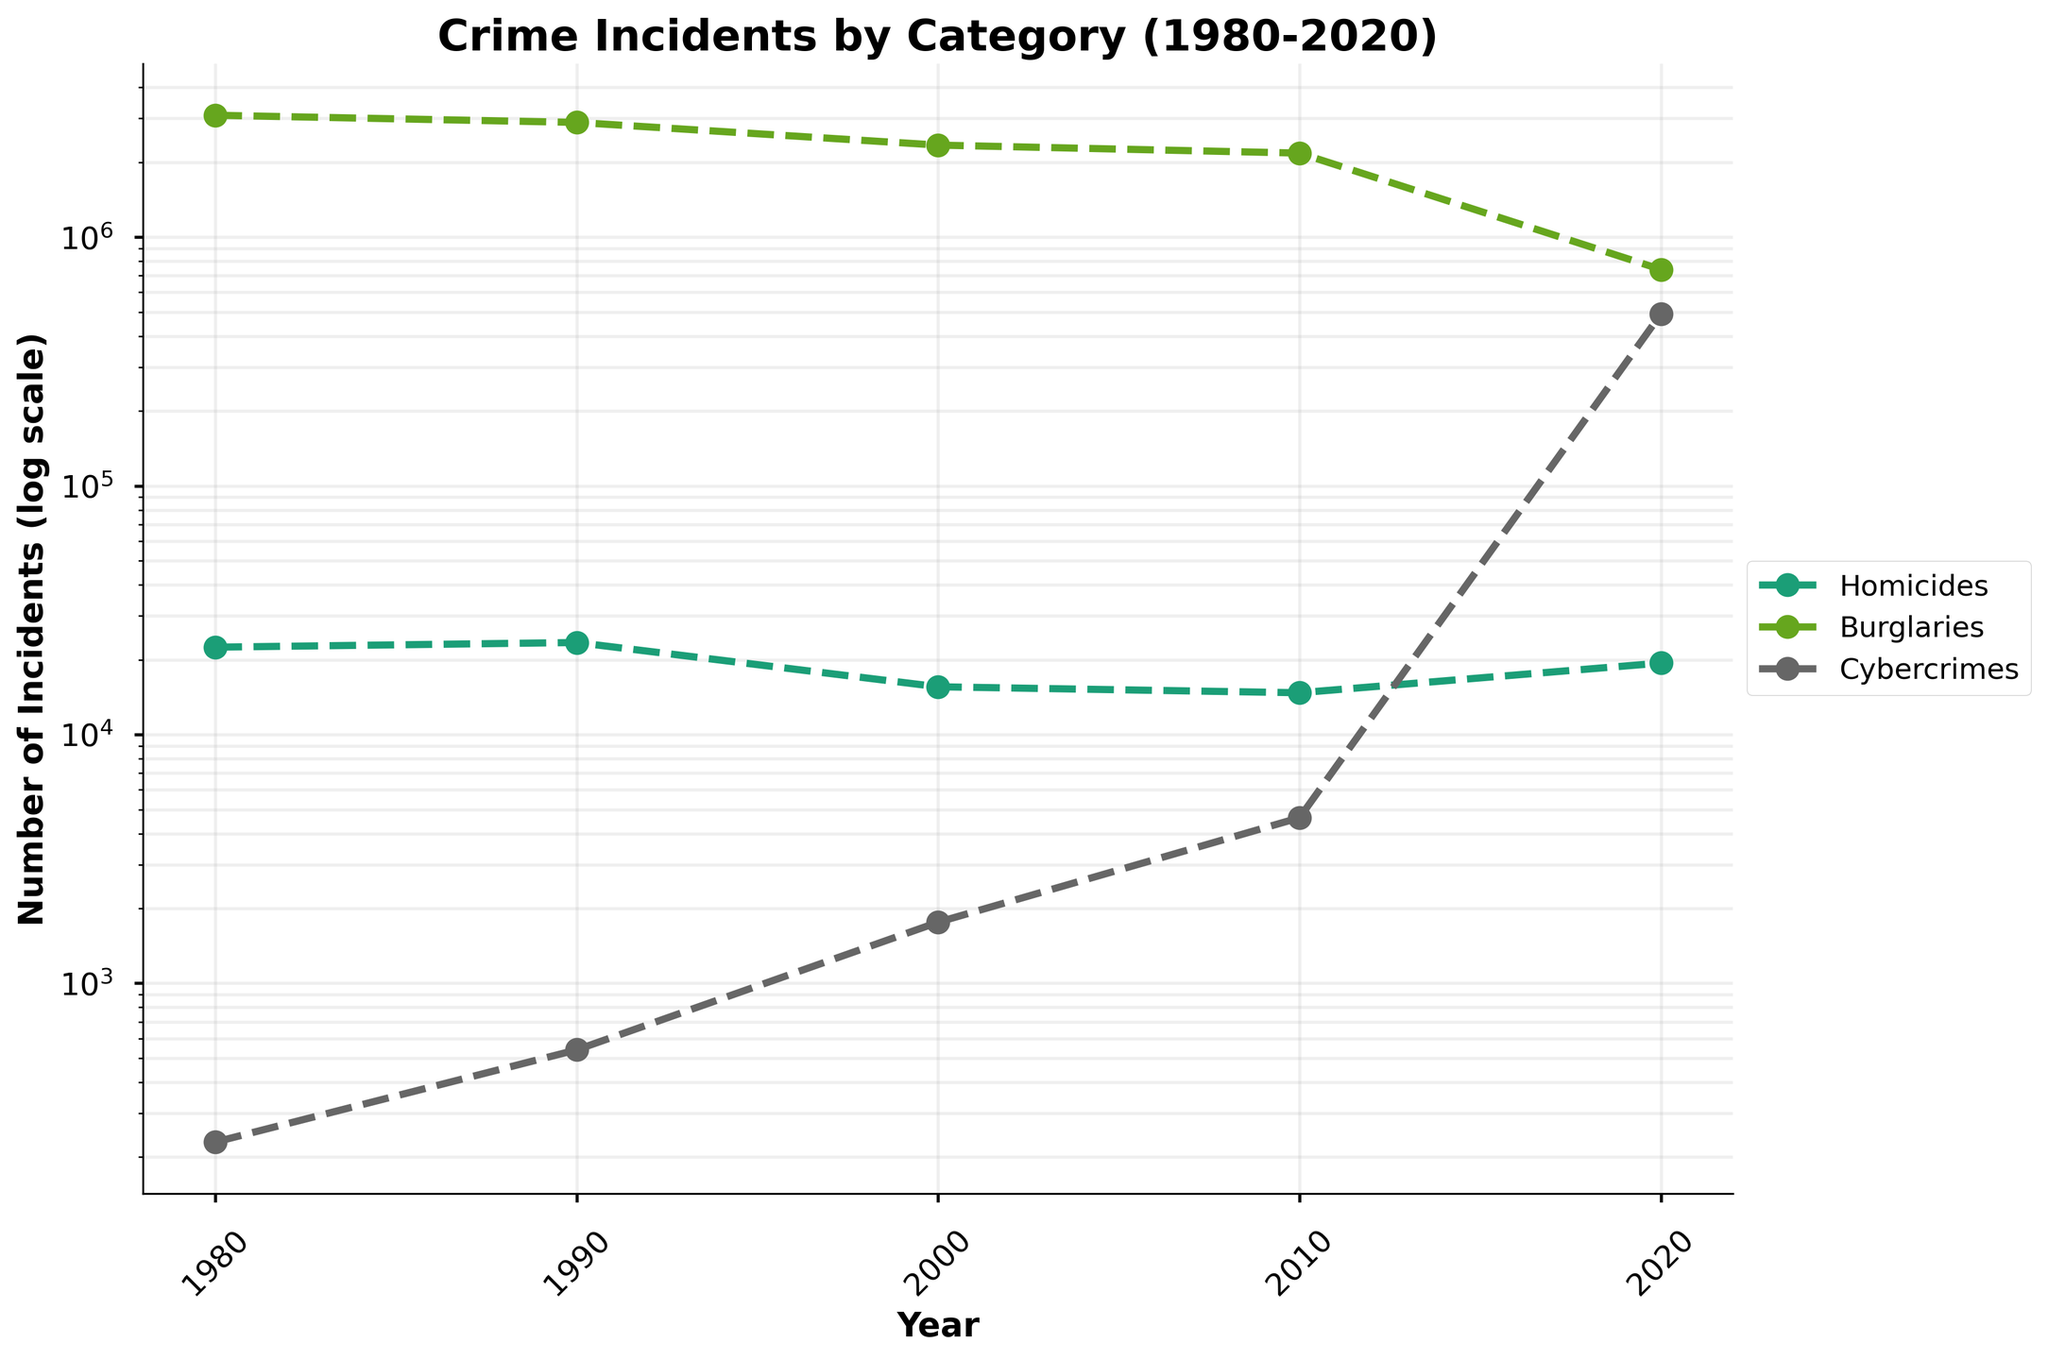What is the title of the figure? The title is typically displayed at the top of the figure and gives an overview of what the figure represents. Here, the title is "Crime Incidents by Category (1980-2020)".
Answer: Crime Incidents by Category (1980-2020) What are the categories displayed in the figure? The categories are typically displayed in the legend. In this figure, the legend shows "Homicides", "Burglaries", and "Cybercrimes".
Answer: Homicides, Burglaries, Cybercrimes How many years are represented in the x-axis of the figure? The x-axis represents the years, which are evenly spaced. By counting the tick marks or labels, it is clear that the years 1980, 1990, 2000, 2010, and 2020 are represented.
Answer: 5 Which category saw the largest increase in incidents between 1980 and 2020? Observing the lines on the log scale plot, Cybercrimes show the steepest upward trend from approximately 230 incidents in 1980 to 490,680 incidents in 2020, indicating the largest increase.
Answer: Cybercrimes What category had the smallest number of incidents in 1980? By examining the data points for the year 1980 on the graph, it is seen that Cybercrimes, positioned much lower on the log scale axis compared to Homicides and Burglaries, had the smallest number of incidents.
Answer: Cybercrimes How did the number of burglaries change from 1980 to 2020? From the log scale, Burglaries showed a decreasing trend over the years, declining from around 3,089,200 incidents in 1980 to about 741,080 incidents in 2020.
Answer: Decreased Which year had the lowest number of homicides? By identifying the lowest data point for the Homicides category, it is clear that the year 2010, with about 14,722 incidents, had the lowest number of homicides.
Answer: 2010 What can you infer about the trend in cybercrimes over the decades? The line representing Cybercrimes on the log scale plot shows a steep and consistent upward trend, which suggests there has been a significant and rapid increase in the number of cybercrime incidents over the decades.
Answer: Increasing rapidly Compare the number of homicides and burglaries in the year 2020. Which category had more incidents? Observing the data points for the year 2020 shows that Burglaries had about 741,080 incidents, whereas Homicides had about 19,380 incidents. Clearly, Burglaries had more incidents.
Answer: Burglaries Considering all categories, in which decade did incidents of crime show the most variability? Examining the lines for each category, the decade between 2010 and 2020 shows the most variability, particularly due to the dramatic increase in Cybercrimes. This can be deduced from the steep changing slopes of the lines in this period.
Answer: 2010-2020 